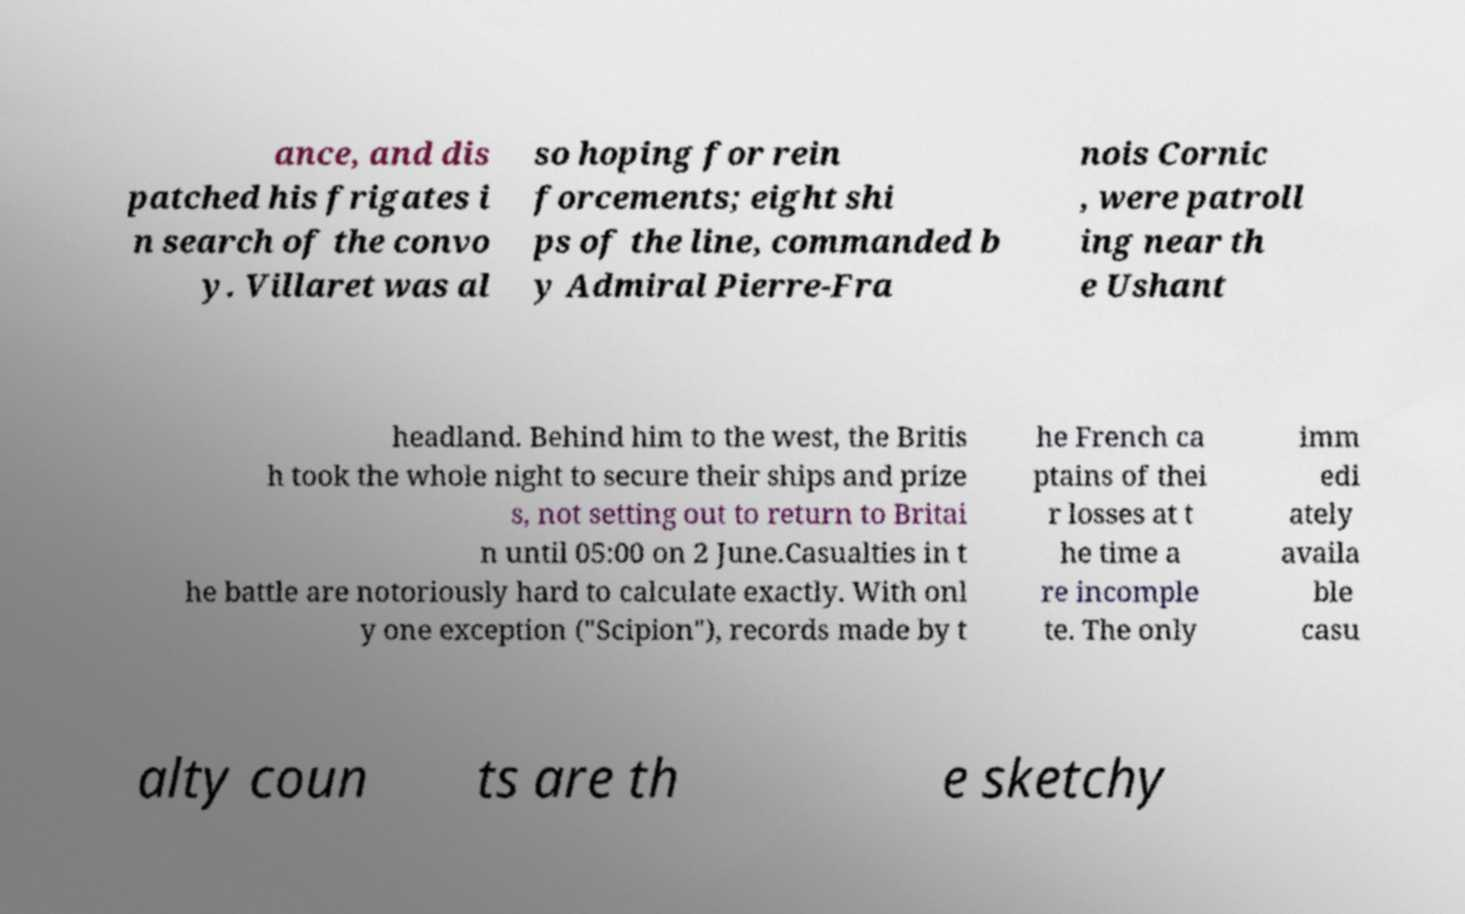I need the written content from this picture converted into text. Can you do that? ance, and dis patched his frigates i n search of the convo y. Villaret was al so hoping for rein forcements; eight shi ps of the line, commanded b y Admiral Pierre-Fra nois Cornic , were patroll ing near th e Ushant headland. Behind him to the west, the Britis h took the whole night to secure their ships and prize s, not setting out to return to Britai n until 05:00 on 2 June.Casualties in t he battle are notoriously hard to calculate exactly. With onl y one exception ("Scipion"), records made by t he French ca ptains of thei r losses at t he time a re incomple te. The only imm edi ately availa ble casu alty coun ts are th e sketchy 